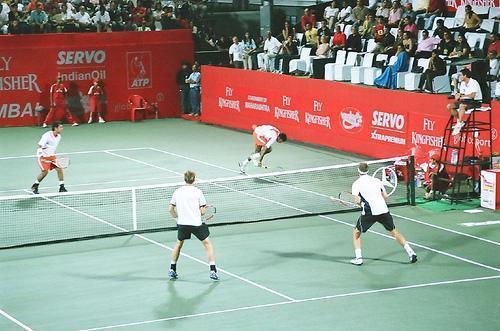How many players are there?
Give a very brief answer. 4. How many people are holding tennis rackets?
Give a very brief answer. 4. How many players are wearing red shorts?
Give a very brief answer. 2. 